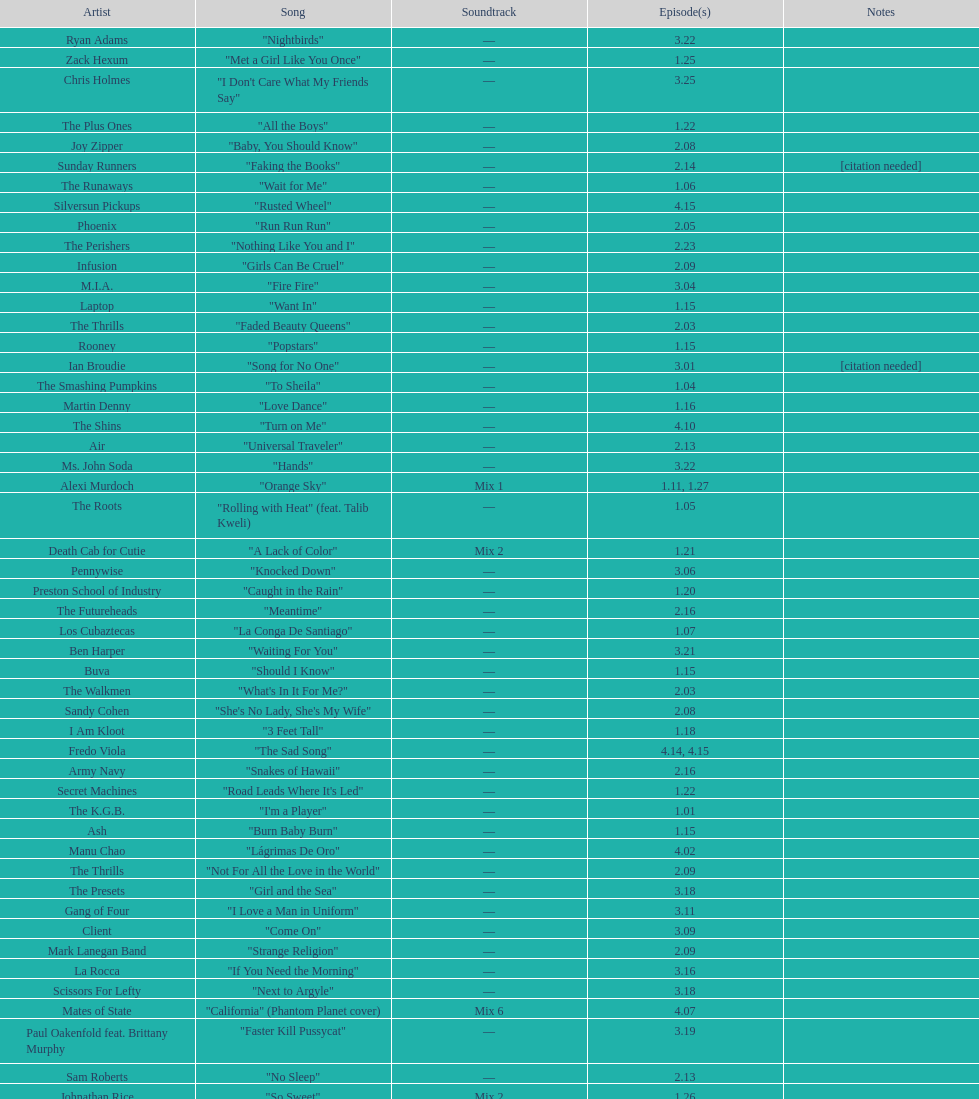How many consecutive songs were by the album leaf? 6. 